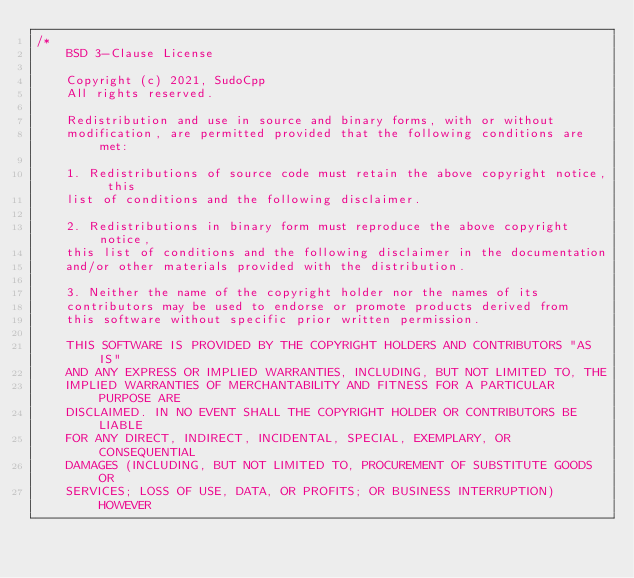Convert code to text. <code><loc_0><loc_0><loc_500><loc_500><_C++_>/*
    BSD 3-Clause License
    
    Copyright (c) 2021, SudoCpp
    All rights reserved.

    Redistribution and use in source and binary forms, with or without
    modification, are permitted provided that the following conditions are met:

    1. Redistributions of source code must retain the above copyright notice, this
    list of conditions and the following disclaimer.

    2. Redistributions in binary form must reproduce the above copyright notice,
    this list of conditions and the following disclaimer in the documentation
    and/or other materials provided with the distribution.

    3. Neither the name of the copyright holder nor the names of its
    contributors may be used to endorse or promote products derived from
    this software without specific prior written permission.

    THIS SOFTWARE IS PROVIDED BY THE COPYRIGHT HOLDERS AND CONTRIBUTORS "AS IS"
    AND ANY EXPRESS OR IMPLIED WARRANTIES, INCLUDING, BUT NOT LIMITED TO, THE
    IMPLIED WARRANTIES OF MERCHANTABILITY AND FITNESS FOR A PARTICULAR PURPOSE ARE
    DISCLAIMED. IN NO EVENT SHALL THE COPYRIGHT HOLDER OR CONTRIBUTORS BE LIABLE
    FOR ANY DIRECT, INDIRECT, INCIDENTAL, SPECIAL, EXEMPLARY, OR CONSEQUENTIAL
    DAMAGES (INCLUDING, BUT NOT LIMITED TO, PROCUREMENT OF SUBSTITUTE GOODS OR
    SERVICES; LOSS OF USE, DATA, OR PROFITS; OR BUSINESS INTERRUPTION) HOWEVER</code> 